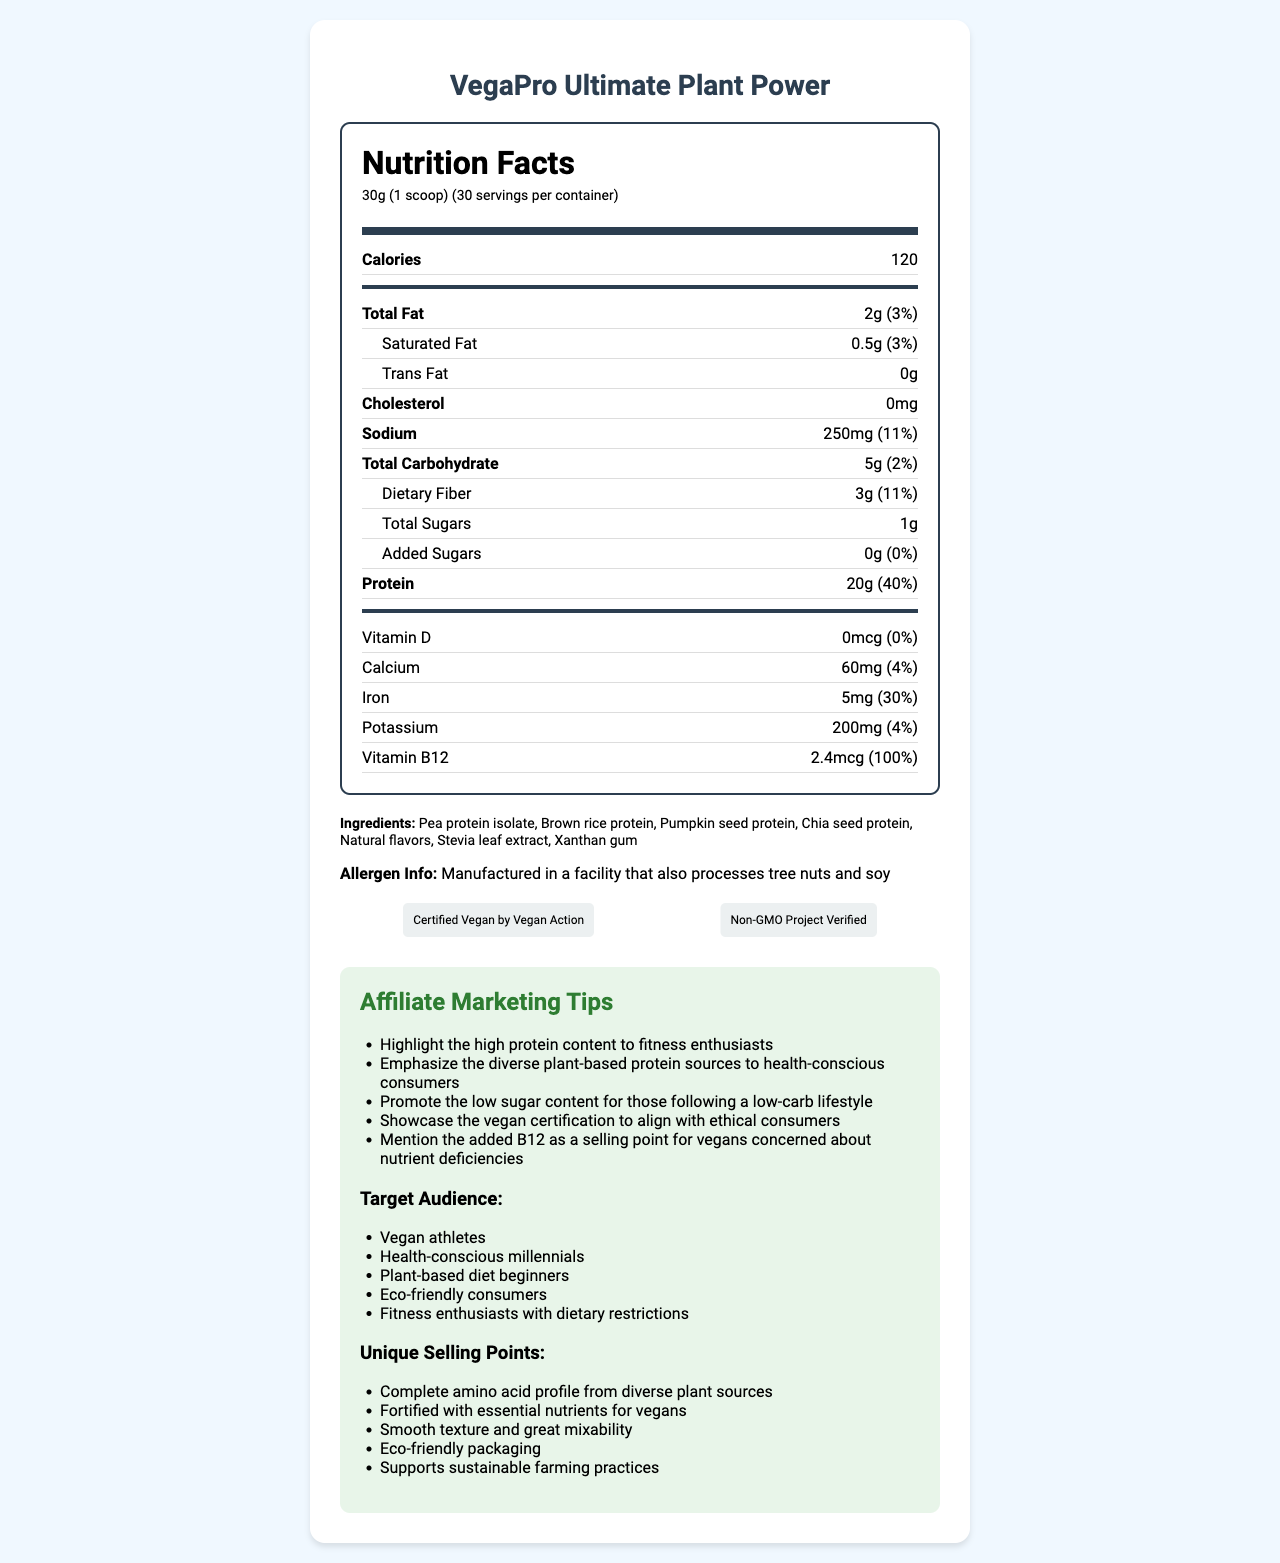what is the serving size of VegaPro Ultimate Plant Power? The serving size is clearly mentioned as 30g (1 scoop) in the document.
Answer: 30g (1 scoop) how many servings are there per container? The document lists that there are 30 servings per container.
Answer: 30 servings how many grams of protein are in one serving? The amount of protein per serving is specified as 20g in the nutrition facts.
Answer: 20g what percentage of the daily value for protein does one serving provide? The document shows that one serving provides 40% of the daily value for protein.
Answer: 40% how much added sugar is in a serving? The added sugars per serving amount to 0g as indicated in the nutritional information.
Answer: 0g what certifications does VegaPro Ultimate Plant Power have? A. Organic B. Non-GMO C. Gluten-Free D. Certified Vegan The document notes that this product is "Non-GMO Project Verified" and "Certified Vegan by Vegan Action."
Answer: B and D how many calories are in one serving? A. 100 B. 120 C. 150 D. 200 The document states that there are 120 calories in one serving.
Answer: B what is the total fat content in one serving? A. 2g B. 4g C. 1g D. 3g The total fat content is mentioned as 2g per serving.
Answer: A is the protein powder certified vegan? The document confirms that it is "Certified Vegan by Vegan Action."
Answer: Yes is this product suitable for individuals avoiding soy? The document indicates it is manufactured in a facility that also processes soy, making it potentially unsuitable for individuals strictly avoiding soy.
Answer: No how much sodium is in a serving? It's clearly stated that there are 250mg of sodium in one serving.
Answer: 250mg how much dietary fiber is in a serving? The dietary fiber content is listed as 3g per serving.
Answer: 3g how many milligrams of potassium are in one serving? The potassium content per serving is specified as 200mg in the document.
Answer: 200mg what type of facility is this product manufactured in? The allergen information section states that the product is manufactured in a facility that processes tree nuts and soy.
Answer: Facility that also processes tree nuts and soy list the main plant-based protein sources used in this product. These sources are listed under the ingredients section in the document.
Answer: Pea protein isolate, Brown rice protein, Pumpkin seed protein, Chia seed protein what is the main purpose of the document? The document serves to inform consumers about the nutritional content, ingredients, allergen information, certifications, and marketing tips for VegaPro Ultimate Plant Power.
Answer: To provide nutritional information and marketing insights for VegaPro Ultimate Plant Power targeting vegan consumers what is the cost of this product? The document does not provide pricing information.
Answer: Cannot be determined 